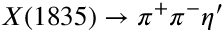<formula> <loc_0><loc_0><loc_500><loc_500>X ( 1 8 3 5 ) \to \pi ^ { + } \pi ^ { - } \eta ^ { \prime }</formula> 